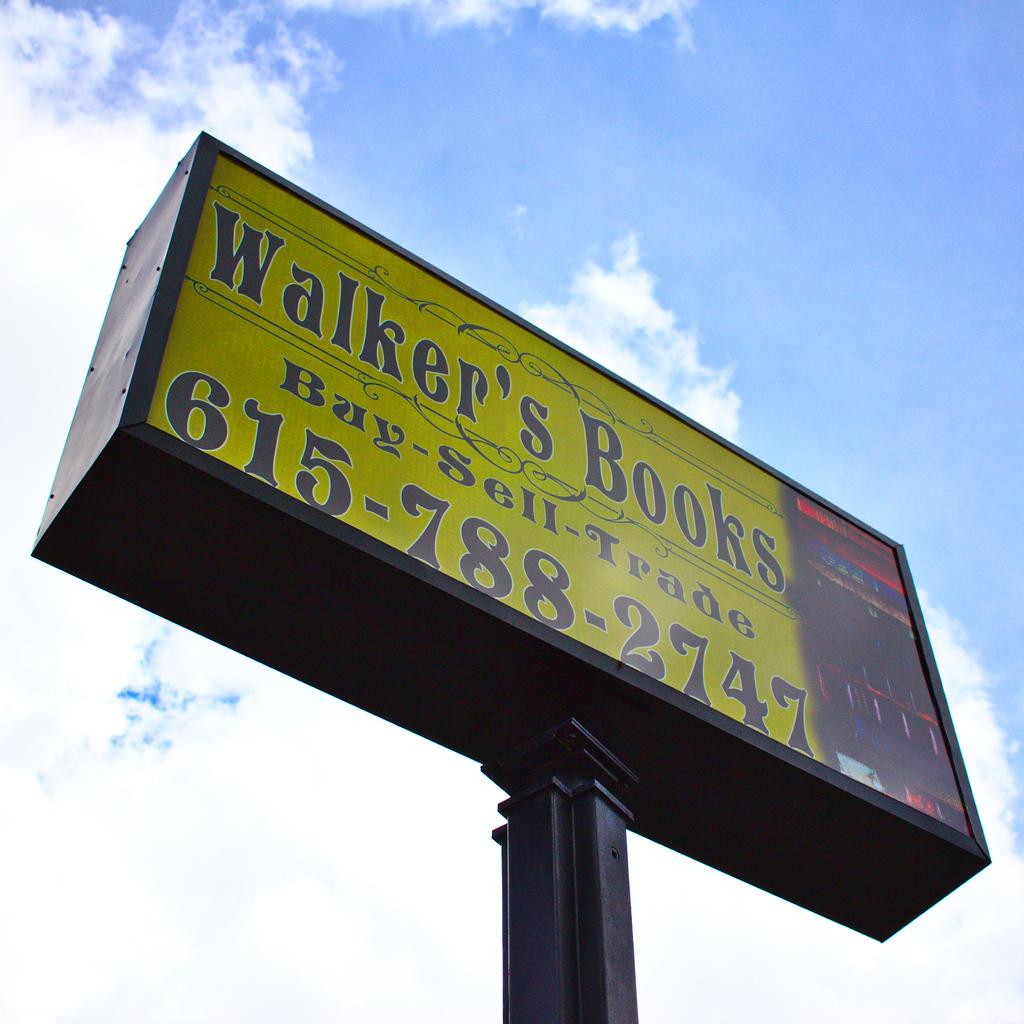What type of item is sold at this store?
Keep it short and to the point. Books. What is the phone number of this business?
Ensure brevity in your answer.  615-788-2747. 